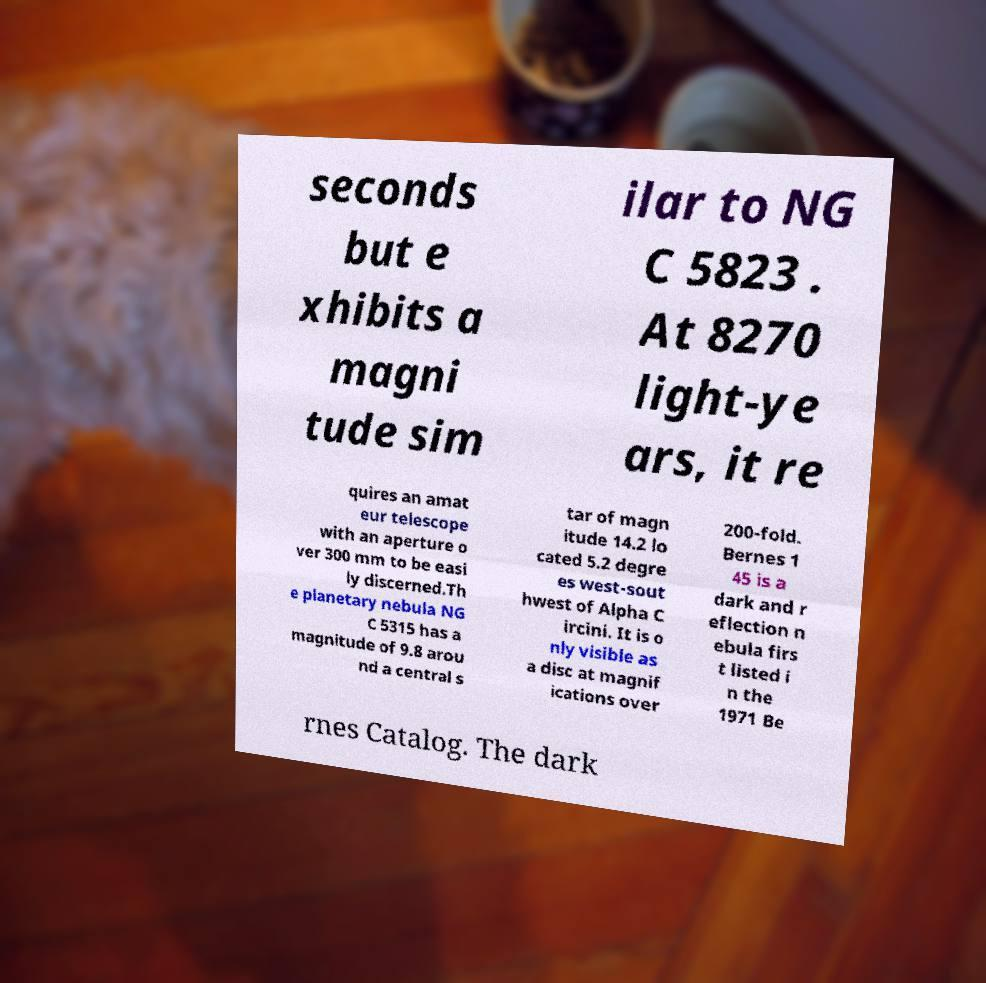Could you assist in decoding the text presented in this image and type it out clearly? seconds but e xhibits a magni tude sim ilar to NG C 5823 . At 8270 light-ye ars, it re quires an amat eur telescope with an aperture o ver 300 mm to be easi ly discerned.Th e planetary nebula NG C 5315 has a magnitude of 9.8 arou nd a central s tar of magn itude 14.2 lo cated 5.2 degre es west-sout hwest of Alpha C ircini. It is o nly visible as a disc at magnif ications over 200-fold. Bernes 1 45 is a dark and r eflection n ebula firs t listed i n the 1971 Be rnes Catalog. The dark 